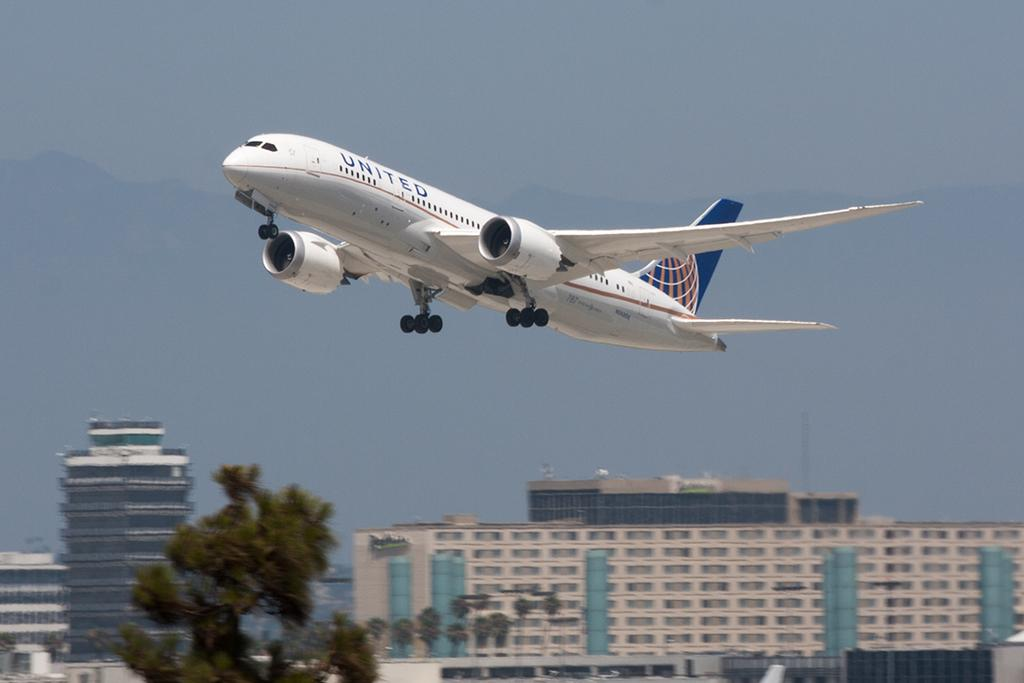<image>
Summarize the visual content of the image. A United Airlines flight takes off into clear skys above a city near the Radisson Hotel 